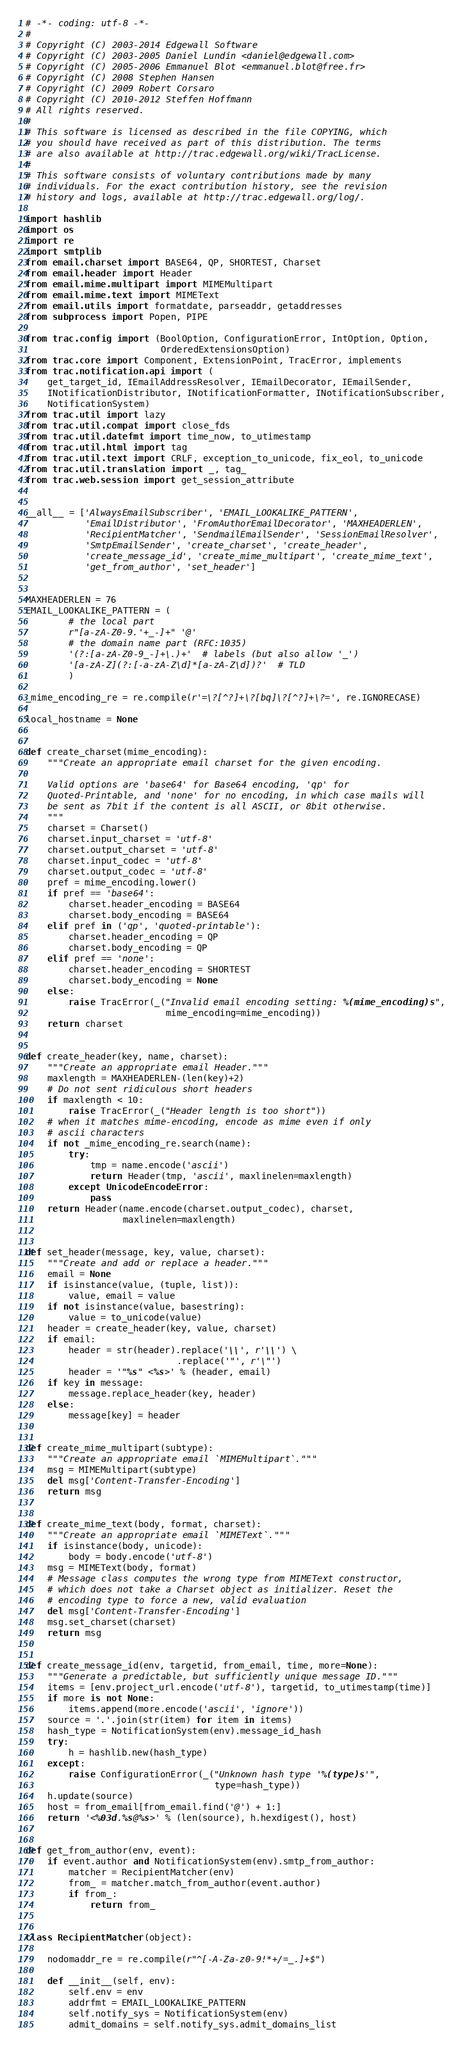Convert code to text. <code><loc_0><loc_0><loc_500><loc_500><_Python_># -*- coding: utf-8 -*-
#
# Copyright (C) 2003-2014 Edgewall Software
# Copyright (C) 2003-2005 Daniel Lundin <daniel@edgewall.com>
# Copyright (C) 2005-2006 Emmanuel Blot <emmanuel.blot@free.fr>
# Copyright (C) 2008 Stephen Hansen
# Copyright (C) 2009 Robert Corsaro
# Copyright (C) 2010-2012 Steffen Hoffmann
# All rights reserved.
#
# This software is licensed as described in the file COPYING, which
# you should have received as part of this distribution. The terms
# are also available at http://trac.edgewall.org/wiki/TracLicense.
#
# This software consists of voluntary contributions made by many
# individuals. For the exact contribution history, see the revision
# history and logs, available at http://trac.edgewall.org/log/.

import hashlib
import os
import re
import smtplib
from email.charset import BASE64, QP, SHORTEST, Charset
from email.header import Header
from email.mime.multipart import MIMEMultipart
from email.mime.text import MIMEText
from email.utils import formatdate, parseaddr, getaddresses
from subprocess import Popen, PIPE

from trac.config import (BoolOption, ConfigurationError, IntOption, Option,
                         OrderedExtensionsOption)
from trac.core import Component, ExtensionPoint, TracError, implements
from trac.notification.api import (
    get_target_id, IEmailAddressResolver, IEmailDecorator, IEmailSender,
    INotificationDistributor, INotificationFormatter, INotificationSubscriber,
    NotificationSystem)
from trac.util import lazy
from trac.util.compat import close_fds
from trac.util.datefmt import time_now, to_utimestamp
from trac.util.html import tag
from trac.util.text import CRLF, exception_to_unicode, fix_eol, to_unicode
from trac.util.translation import _, tag_
from trac.web.session import get_session_attribute


__all__ = ['AlwaysEmailSubscriber', 'EMAIL_LOOKALIKE_PATTERN',
           'EmailDistributor', 'FromAuthorEmailDecorator', 'MAXHEADERLEN',
           'RecipientMatcher', 'SendmailEmailSender', 'SessionEmailResolver',
           'SmtpEmailSender', 'create_charset', 'create_header',
           'create_message_id', 'create_mime_multipart', 'create_mime_text',
           'get_from_author', 'set_header']


MAXHEADERLEN = 76
EMAIL_LOOKALIKE_PATTERN = (
        # the local part
        r"[a-zA-Z0-9.'+_-]+" '@'
        # the domain name part (RFC:1035)
        '(?:[a-zA-Z0-9_-]+\.)+'  # labels (but also allow '_')
        '[a-zA-Z](?:[-a-zA-Z\d]*[a-zA-Z\d])?'  # TLD
        )

_mime_encoding_re = re.compile(r'=\?[^?]+\?[bq]\?[^?]+\?=', re.IGNORECASE)

local_hostname = None


def create_charset(mime_encoding):
    """Create an appropriate email charset for the given encoding.

    Valid options are 'base64' for Base64 encoding, 'qp' for
    Quoted-Printable, and 'none' for no encoding, in which case mails will
    be sent as 7bit if the content is all ASCII, or 8bit otherwise.
    """
    charset = Charset()
    charset.input_charset = 'utf-8'
    charset.output_charset = 'utf-8'
    charset.input_codec = 'utf-8'
    charset.output_codec = 'utf-8'
    pref = mime_encoding.lower()
    if pref == 'base64':
        charset.header_encoding = BASE64
        charset.body_encoding = BASE64
    elif pref in ('qp', 'quoted-printable'):
        charset.header_encoding = QP
        charset.body_encoding = QP
    elif pref == 'none':
        charset.header_encoding = SHORTEST
        charset.body_encoding = None
    else:
        raise TracError(_("Invalid email encoding setting: %(mime_encoding)s",
                          mime_encoding=mime_encoding))
    return charset


def create_header(key, name, charset):
    """Create an appropriate email Header."""
    maxlength = MAXHEADERLEN-(len(key)+2)
    # Do not sent ridiculous short headers
    if maxlength < 10:
        raise TracError(_("Header length is too short"))
    # when it matches mime-encoding, encode as mime even if only
    # ascii characters
    if not _mime_encoding_re.search(name):
        try:
            tmp = name.encode('ascii')
            return Header(tmp, 'ascii', maxlinelen=maxlength)
        except UnicodeEncodeError:
            pass
    return Header(name.encode(charset.output_codec), charset,
                  maxlinelen=maxlength)


def set_header(message, key, value, charset):
    """Create and add or replace a header."""
    email = None
    if isinstance(value, (tuple, list)):
        value, email = value
    if not isinstance(value, basestring):
        value = to_unicode(value)
    header = create_header(key, value, charset)
    if email:
        header = str(header).replace('\\', r'\\') \
                            .replace('"', r'\"')
        header = '"%s" <%s>' % (header, email)
    if key in message:
        message.replace_header(key, header)
    else:
        message[key] = header


def create_mime_multipart(subtype):
    """Create an appropriate email `MIMEMultipart`."""
    msg = MIMEMultipart(subtype)
    del msg['Content-Transfer-Encoding']
    return msg


def create_mime_text(body, format, charset):
    """Create an appropriate email `MIMEText`."""
    if isinstance(body, unicode):
        body = body.encode('utf-8')
    msg = MIMEText(body, format)
    # Message class computes the wrong type from MIMEText constructor,
    # which does not take a Charset object as initializer. Reset the
    # encoding type to force a new, valid evaluation
    del msg['Content-Transfer-Encoding']
    msg.set_charset(charset)
    return msg


def create_message_id(env, targetid, from_email, time, more=None):
    """Generate a predictable, but sufficiently unique message ID."""
    items = [env.project_url.encode('utf-8'), targetid, to_utimestamp(time)]
    if more is not None:
        items.append(more.encode('ascii', 'ignore'))
    source = '.'.join(str(item) for item in items)
    hash_type = NotificationSystem(env).message_id_hash
    try:
        h = hashlib.new(hash_type)
    except:
        raise ConfigurationError(_("Unknown hash type '%(type)s'",
                                   type=hash_type))
    h.update(source)
    host = from_email[from_email.find('@') + 1:]
    return '<%03d.%s@%s>' % (len(source), h.hexdigest(), host)


def get_from_author(env, event):
    if event.author and NotificationSystem(env).smtp_from_author:
        matcher = RecipientMatcher(env)
        from_ = matcher.match_from_author(event.author)
        if from_:
            return from_


class RecipientMatcher(object):

    nodomaddr_re = re.compile(r"^[-A-Za-z0-9!*+/=_.]+$")

    def __init__(self, env):
        self.env = env
        addrfmt = EMAIL_LOOKALIKE_PATTERN
        self.notify_sys = NotificationSystem(env)
        admit_domains = self.notify_sys.admit_domains_list</code> 